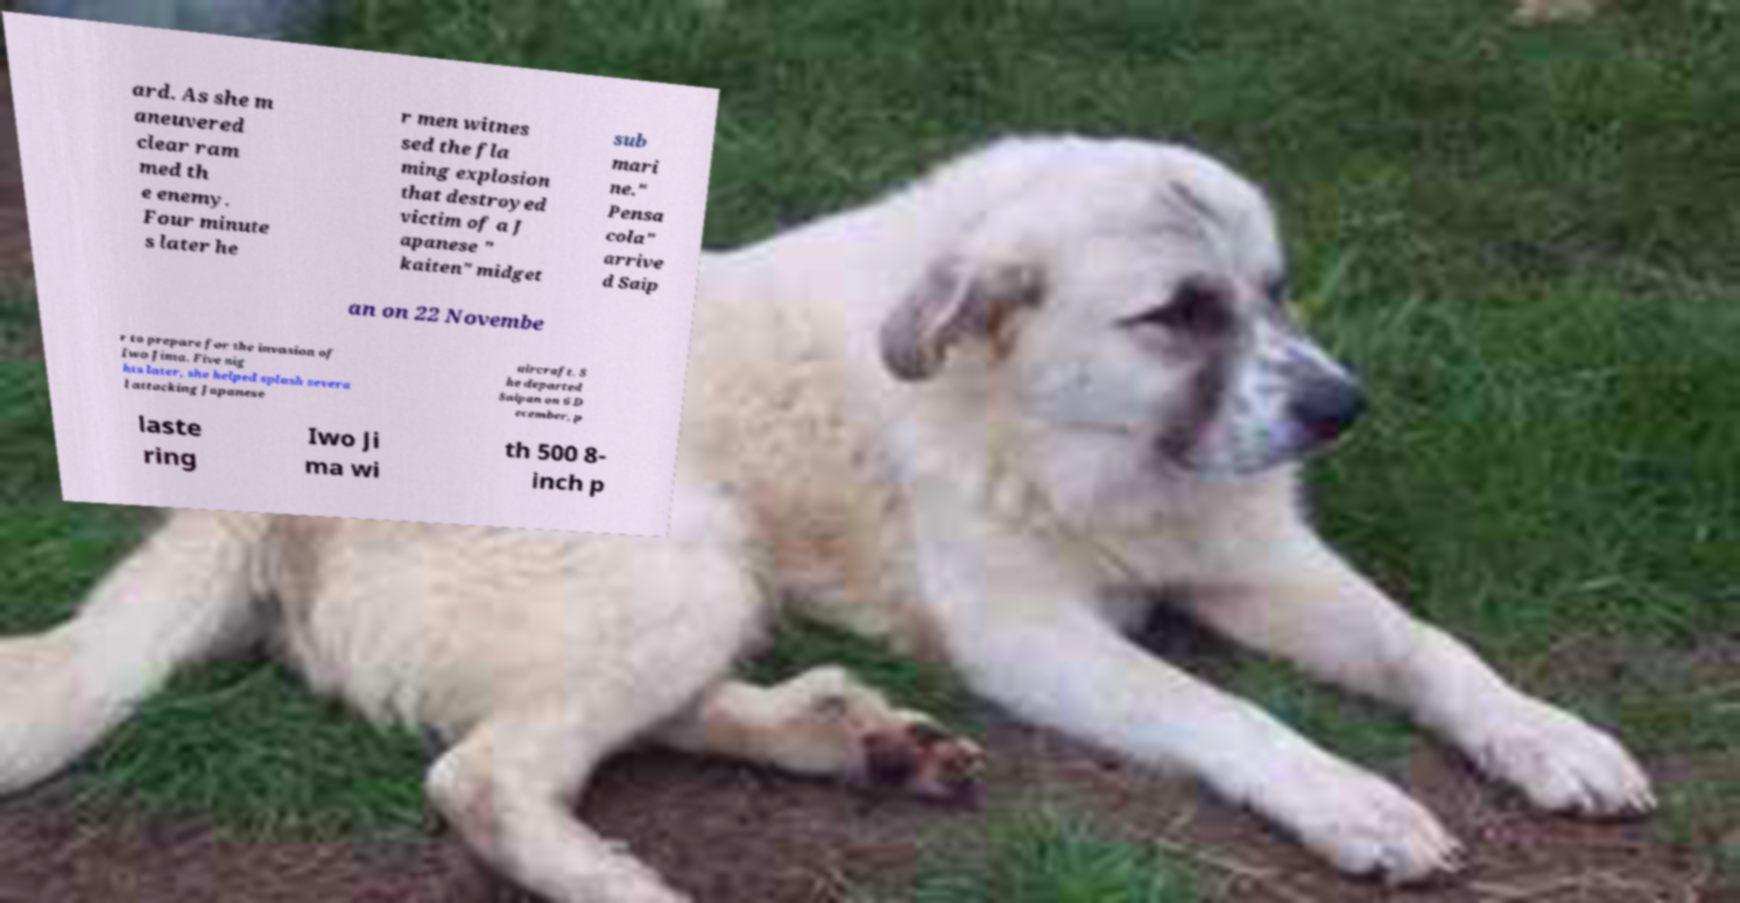There's text embedded in this image that I need extracted. Can you transcribe it verbatim? ard. As she m aneuvered clear ram med th e enemy. Four minute s later he r men witnes sed the fla ming explosion that destroyed victim of a J apanese " kaiten" midget sub mari ne." Pensa cola" arrive d Saip an on 22 Novembe r to prepare for the invasion of Iwo Jima. Five nig hts later, she helped splash severa l attacking Japanese aircraft. S he departed Saipan on 6 D ecember, p laste ring Iwo Ji ma wi th 500 8- inch p 